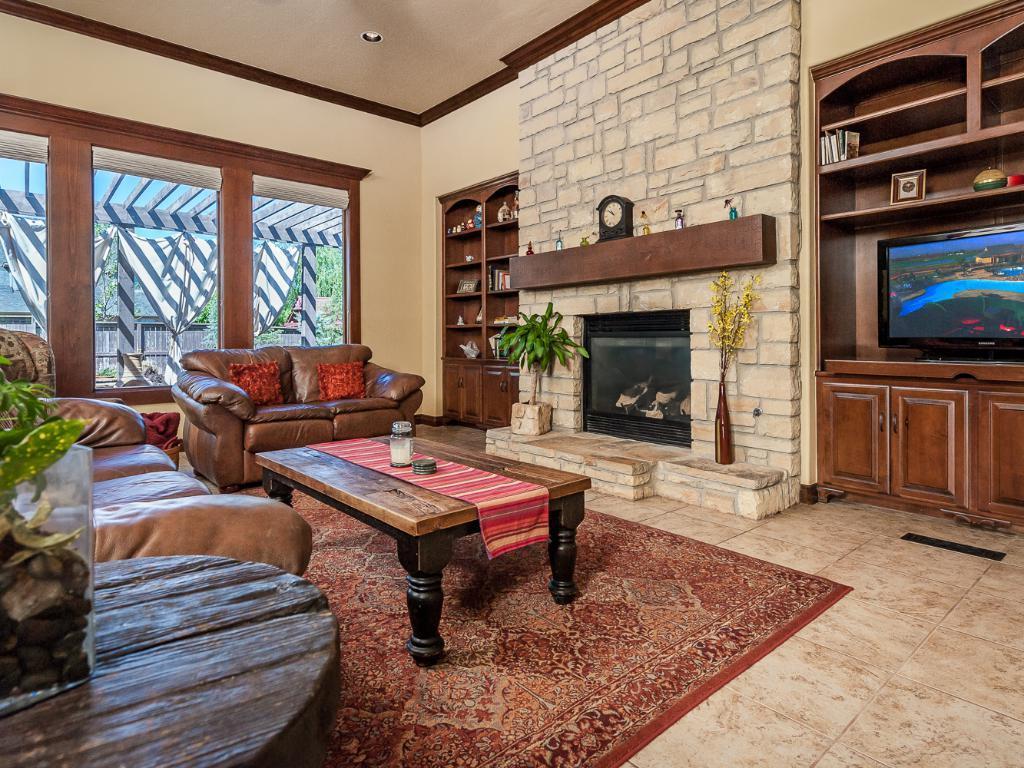Describe this image in one or two sentences. The image is inside the room. In the image on right side we can see a television,plants,flower pots, shelf on left side we can see a table. On table there is a plant and a flower pot in middle there is a couch with pillows and there is a tablecloth,jar. in background there is a glass door which is closed,trees on top there is a roof at bottom there is a red color mat. 